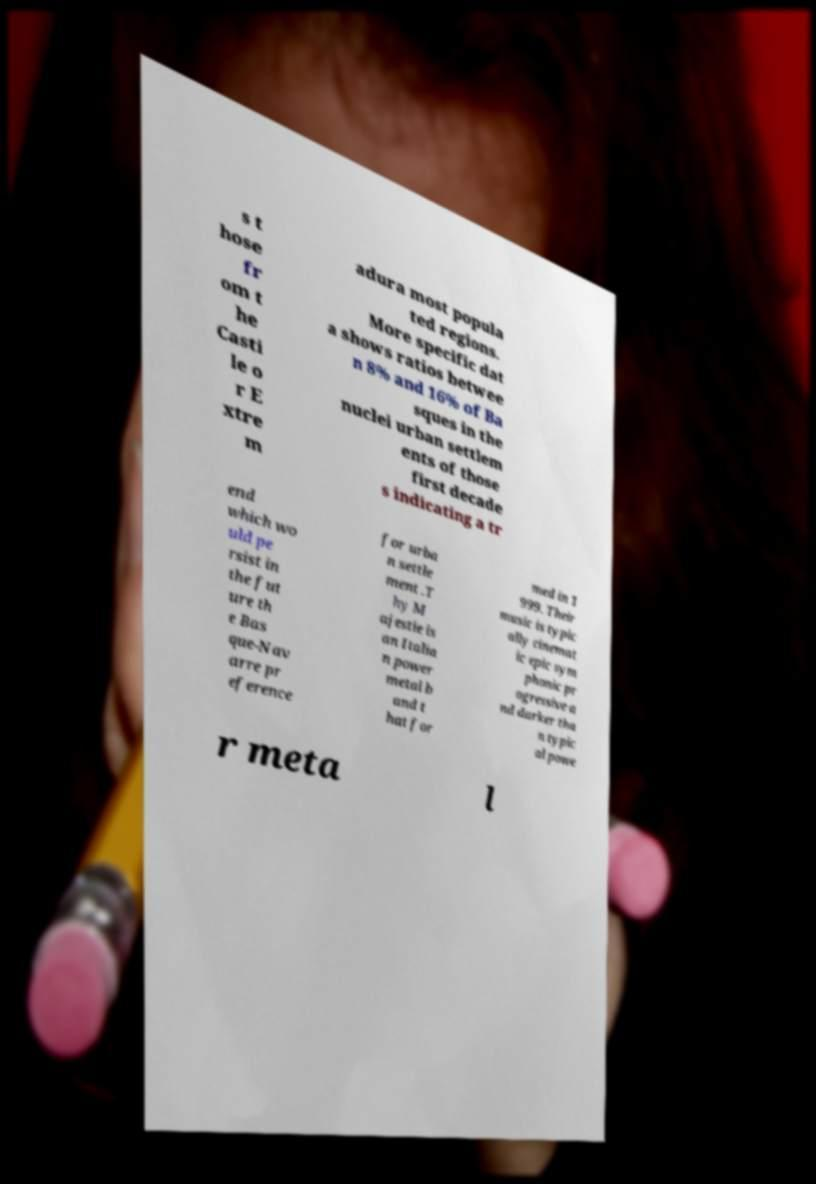Can you read and provide the text displayed in the image?This photo seems to have some interesting text. Can you extract and type it out for me? s t hose fr om t he Casti le o r E xtre m adura most popula ted regions. More specific dat a shows ratios betwee n 8% and 16% of Ba sques in the nuclei urban settlem ents of those first decade s indicating a tr end which wo uld pe rsist in the fut ure th e Bas que-Nav arre pr eference for urba n settle ment .T hy M ajestie is an Italia n power metal b and t hat for med in 1 999. Their music is typic ally cinemat ic epic sym phonic pr ogressive a nd darker tha n typic al powe r meta l 